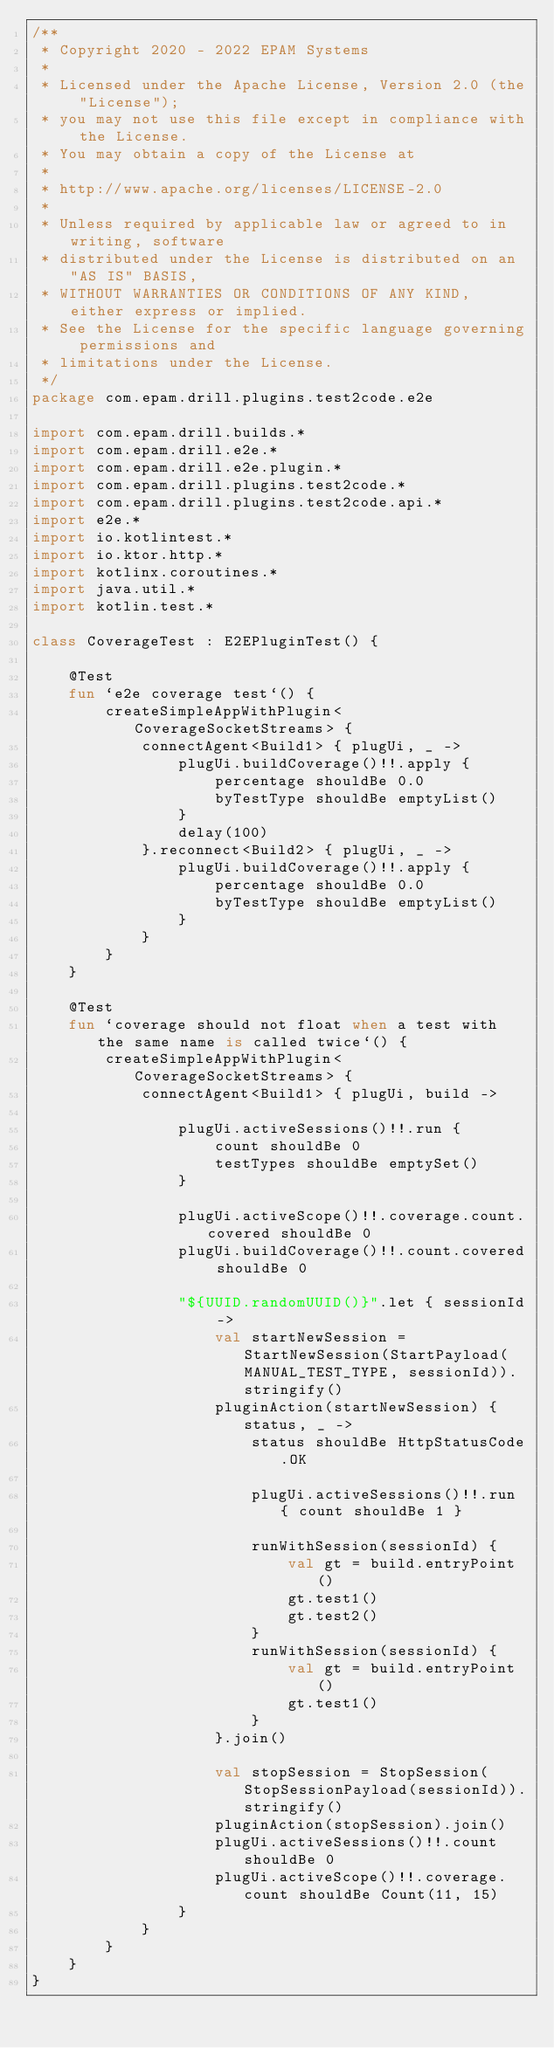Convert code to text. <code><loc_0><loc_0><loc_500><loc_500><_Kotlin_>/**
 * Copyright 2020 - 2022 EPAM Systems
 *
 * Licensed under the Apache License, Version 2.0 (the "License");
 * you may not use this file except in compliance with the License.
 * You may obtain a copy of the License at
 *
 * http://www.apache.org/licenses/LICENSE-2.0
 *
 * Unless required by applicable law or agreed to in writing, software
 * distributed under the License is distributed on an "AS IS" BASIS,
 * WITHOUT WARRANTIES OR CONDITIONS OF ANY KIND, either express or implied.
 * See the License for the specific language governing permissions and
 * limitations under the License.
 */
package com.epam.drill.plugins.test2code.e2e

import com.epam.drill.builds.*
import com.epam.drill.e2e.*
import com.epam.drill.e2e.plugin.*
import com.epam.drill.plugins.test2code.*
import com.epam.drill.plugins.test2code.api.*
import e2e.*
import io.kotlintest.*
import io.ktor.http.*
import kotlinx.coroutines.*
import java.util.*
import kotlin.test.*

class CoverageTest : E2EPluginTest() {

    @Test
    fun `e2e coverage test`() {
        createSimpleAppWithPlugin<CoverageSocketStreams> {
            connectAgent<Build1> { plugUi, _ ->
                plugUi.buildCoverage()!!.apply {
                    percentage shouldBe 0.0
                    byTestType shouldBe emptyList()
                }
                delay(100)
            }.reconnect<Build2> { plugUi, _ ->
                plugUi.buildCoverage()!!.apply {
                    percentage shouldBe 0.0
                    byTestType shouldBe emptyList()
                }
            }
        }
    }

    @Test
    fun `coverage should not float when a test with the same name is called twice`() {
        createSimpleAppWithPlugin<CoverageSocketStreams> {
            connectAgent<Build1> { plugUi, build ->

                plugUi.activeSessions()!!.run {
                    count shouldBe 0
                    testTypes shouldBe emptySet()
                }

                plugUi.activeScope()!!.coverage.count.covered shouldBe 0
                plugUi.buildCoverage()!!.count.covered shouldBe 0

                "${UUID.randomUUID()}".let { sessionId ->
                    val startNewSession = StartNewSession(StartPayload(MANUAL_TEST_TYPE, sessionId)).stringify()
                    pluginAction(startNewSession) { status, _ ->
                        status shouldBe HttpStatusCode.OK

                        plugUi.activeSessions()!!.run { count shouldBe 1 }

                        runWithSession(sessionId) {
                            val gt = build.entryPoint()
                            gt.test1()
                            gt.test2()
                        }
                        runWithSession(sessionId) {
                            val gt = build.entryPoint()
                            gt.test1()
                        }
                    }.join()

                    val stopSession = StopSession(StopSessionPayload(sessionId)).stringify()
                    pluginAction(stopSession).join()
                    plugUi.activeSessions()!!.count shouldBe 0
                    plugUi.activeScope()!!.coverage.count shouldBe Count(11, 15)
                }
            }
        }
    }
}
</code> 